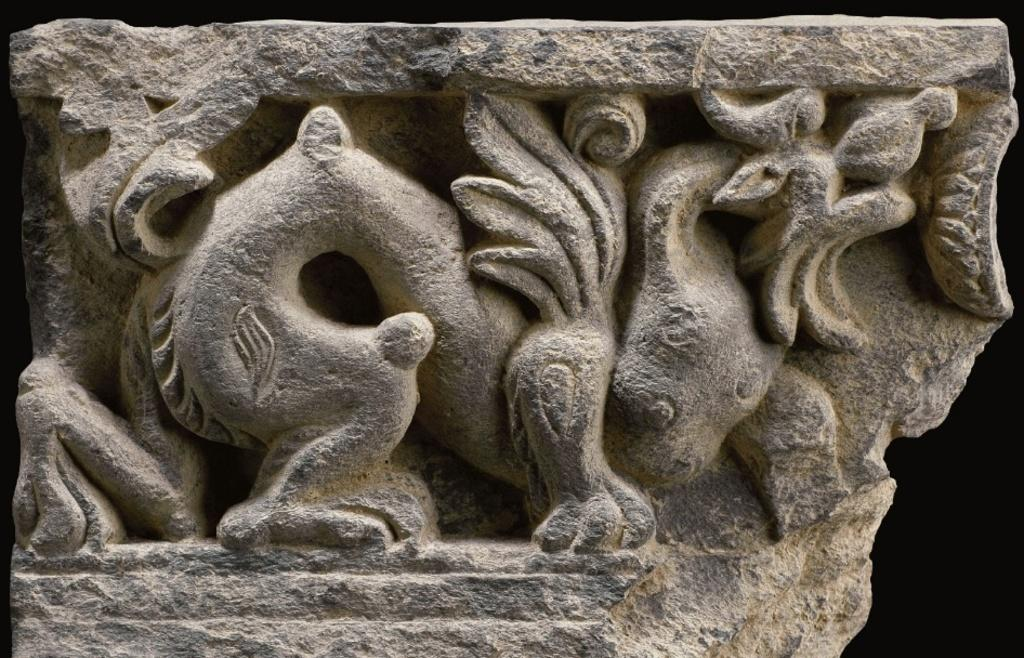What is the main subject in the image? There is a sculpture in the image. Where is the sculpture located? The sculpture is on a rock. How does the sculpture balance on the rock while playing basketball in the image? There is no basketball or any indication of the sculpture balancing or playing basketball in the image. 